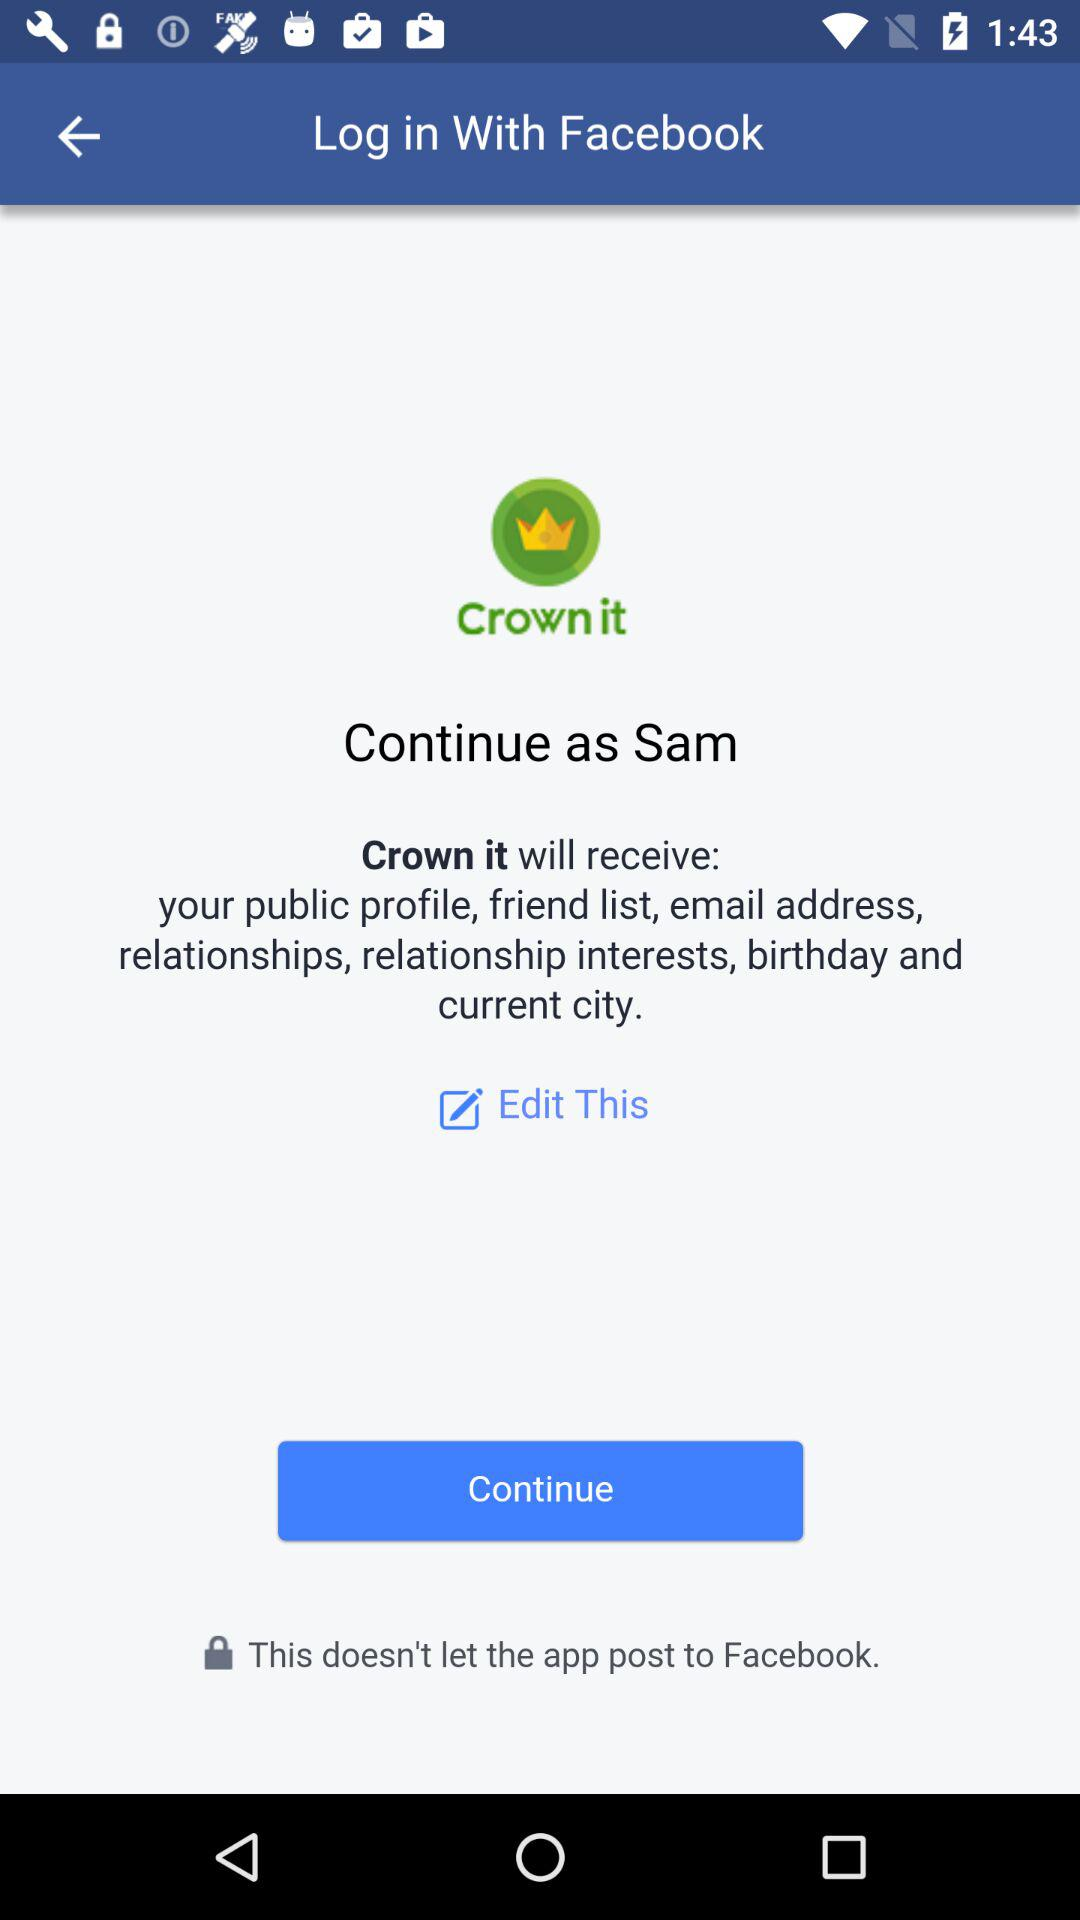What information will "Crown it" receive? "Crown it" will receive your public profile, friend list, email address, relationships, relationship interests, birthday and current city. 